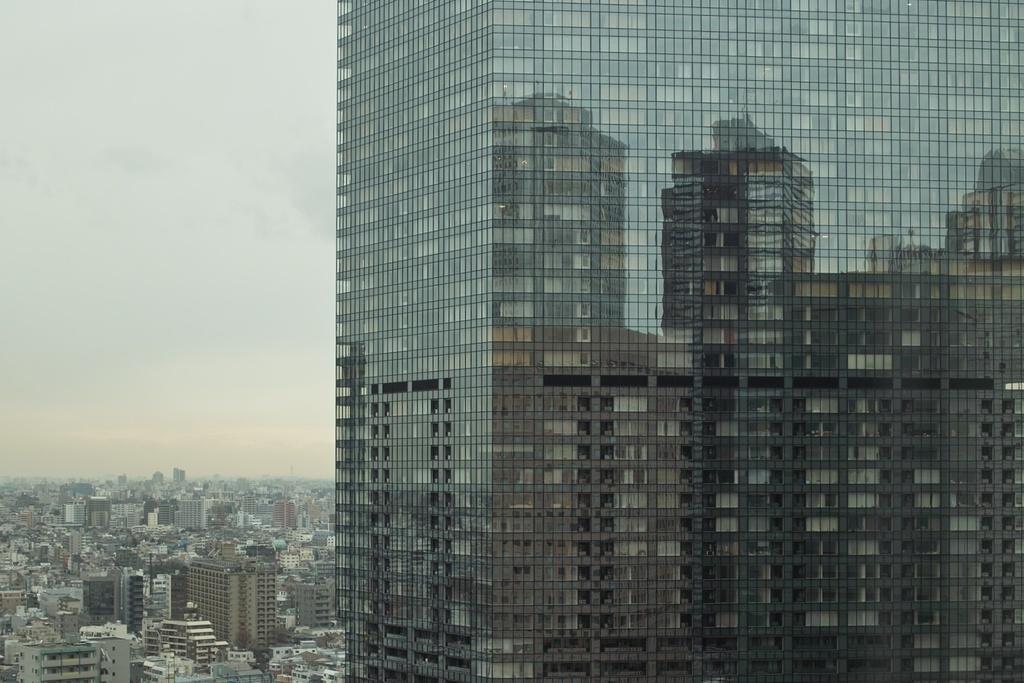Please provide a concise description of this image. In this image, we can see a glass building. On the glasses, there are few reflections. On the left side of the image, we can see the sky, buildings and trees. 